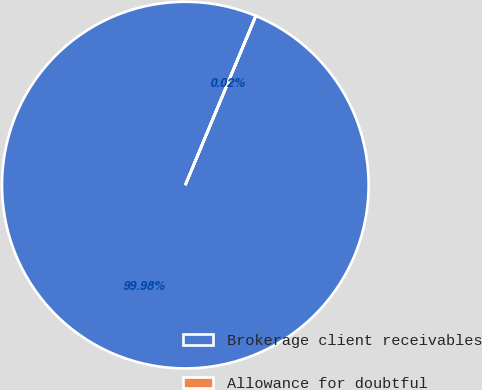Convert chart to OTSL. <chart><loc_0><loc_0><loc_500><loc_500><pie_chart><fcel>Brokerage client receivables<fcel>Allowance for doubtful<nl><fcel>99.98%<fcel>0.02%<nl></chart> 